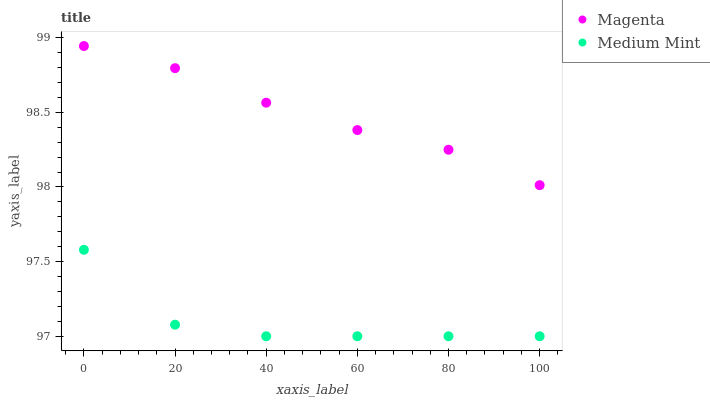Does Medium Mint have the minimum area under the curve?
Answer yes or no. Yes. Does Magenta have the maximum area under the curve?
Answer yes or no. Yes. Does Magenta have the minimum area under the curve?
Answer yes or no. No. Is Magenta the smoothest?
Answer yes or no. Yes. Is Medium Mint the roughest?
Answer yes or no. Yes. Is Magenta the roughest?
Answer yes or no. No. Does Medium Mint have the lowest value?
Answer yes or no. Yes. Does Magenta have the lowest value?
Answer yes or no. No. Does Magenta have the highest value?
Answer yes or no. Yes. Is Medium Mint less than Magenta?
Answer yes or no. Yes. Is Magenta greater than Medium Mint?
Answer yes or no. Yes. Does Medium Mint intersect Magenta?
Answer yes or no. No. 